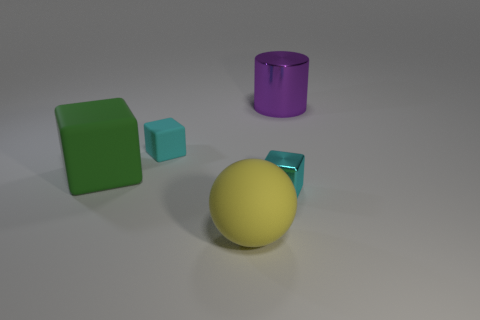Are there any big cylinders made of the same material as the large green thing?
Your response must be concise. No. The rubber cube that is the same color as the tiny metallic block is what size?
Ensure brevity in your answer.  Small. What number of cubes are tiny cyan rubber objects or tiny cyan metallic objects?
Ensure brevity in your answer.  2. Is the number of green objects that are behind the large matte sphere greater than the number of tiny objects on the right side of the cyan shiny cube?
Your response must be concise. Yes. How many other big balls have the same color as the big rubber sphere?
Ensure brevity in your answer.  0. There is a cyan thing that is made of the same material as the big sphere; what is its size?
Ensure brevity in your answer.  Small. How many objects are things in front of the purple thing or large blue spheres?
Keep it short and to the point. 4. Does the metallic object left of the metal cylinder have the same color as the small matte object?
Your answer should be very brief. Yes. What size is the cyan matte object that is the same shape as the tiny cyan shiny object?
Offer a terse response. Small. What color is the large matte object in front of the metallic thing on the left side of the metallic object that is behind the large green object?
Provide a short and direct response. Yellow. 